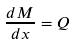Convert formula to latex. <formula><loc_0><loc_0><loc_500><loc_500>\frac { d M } { d x } = Q</formula> 